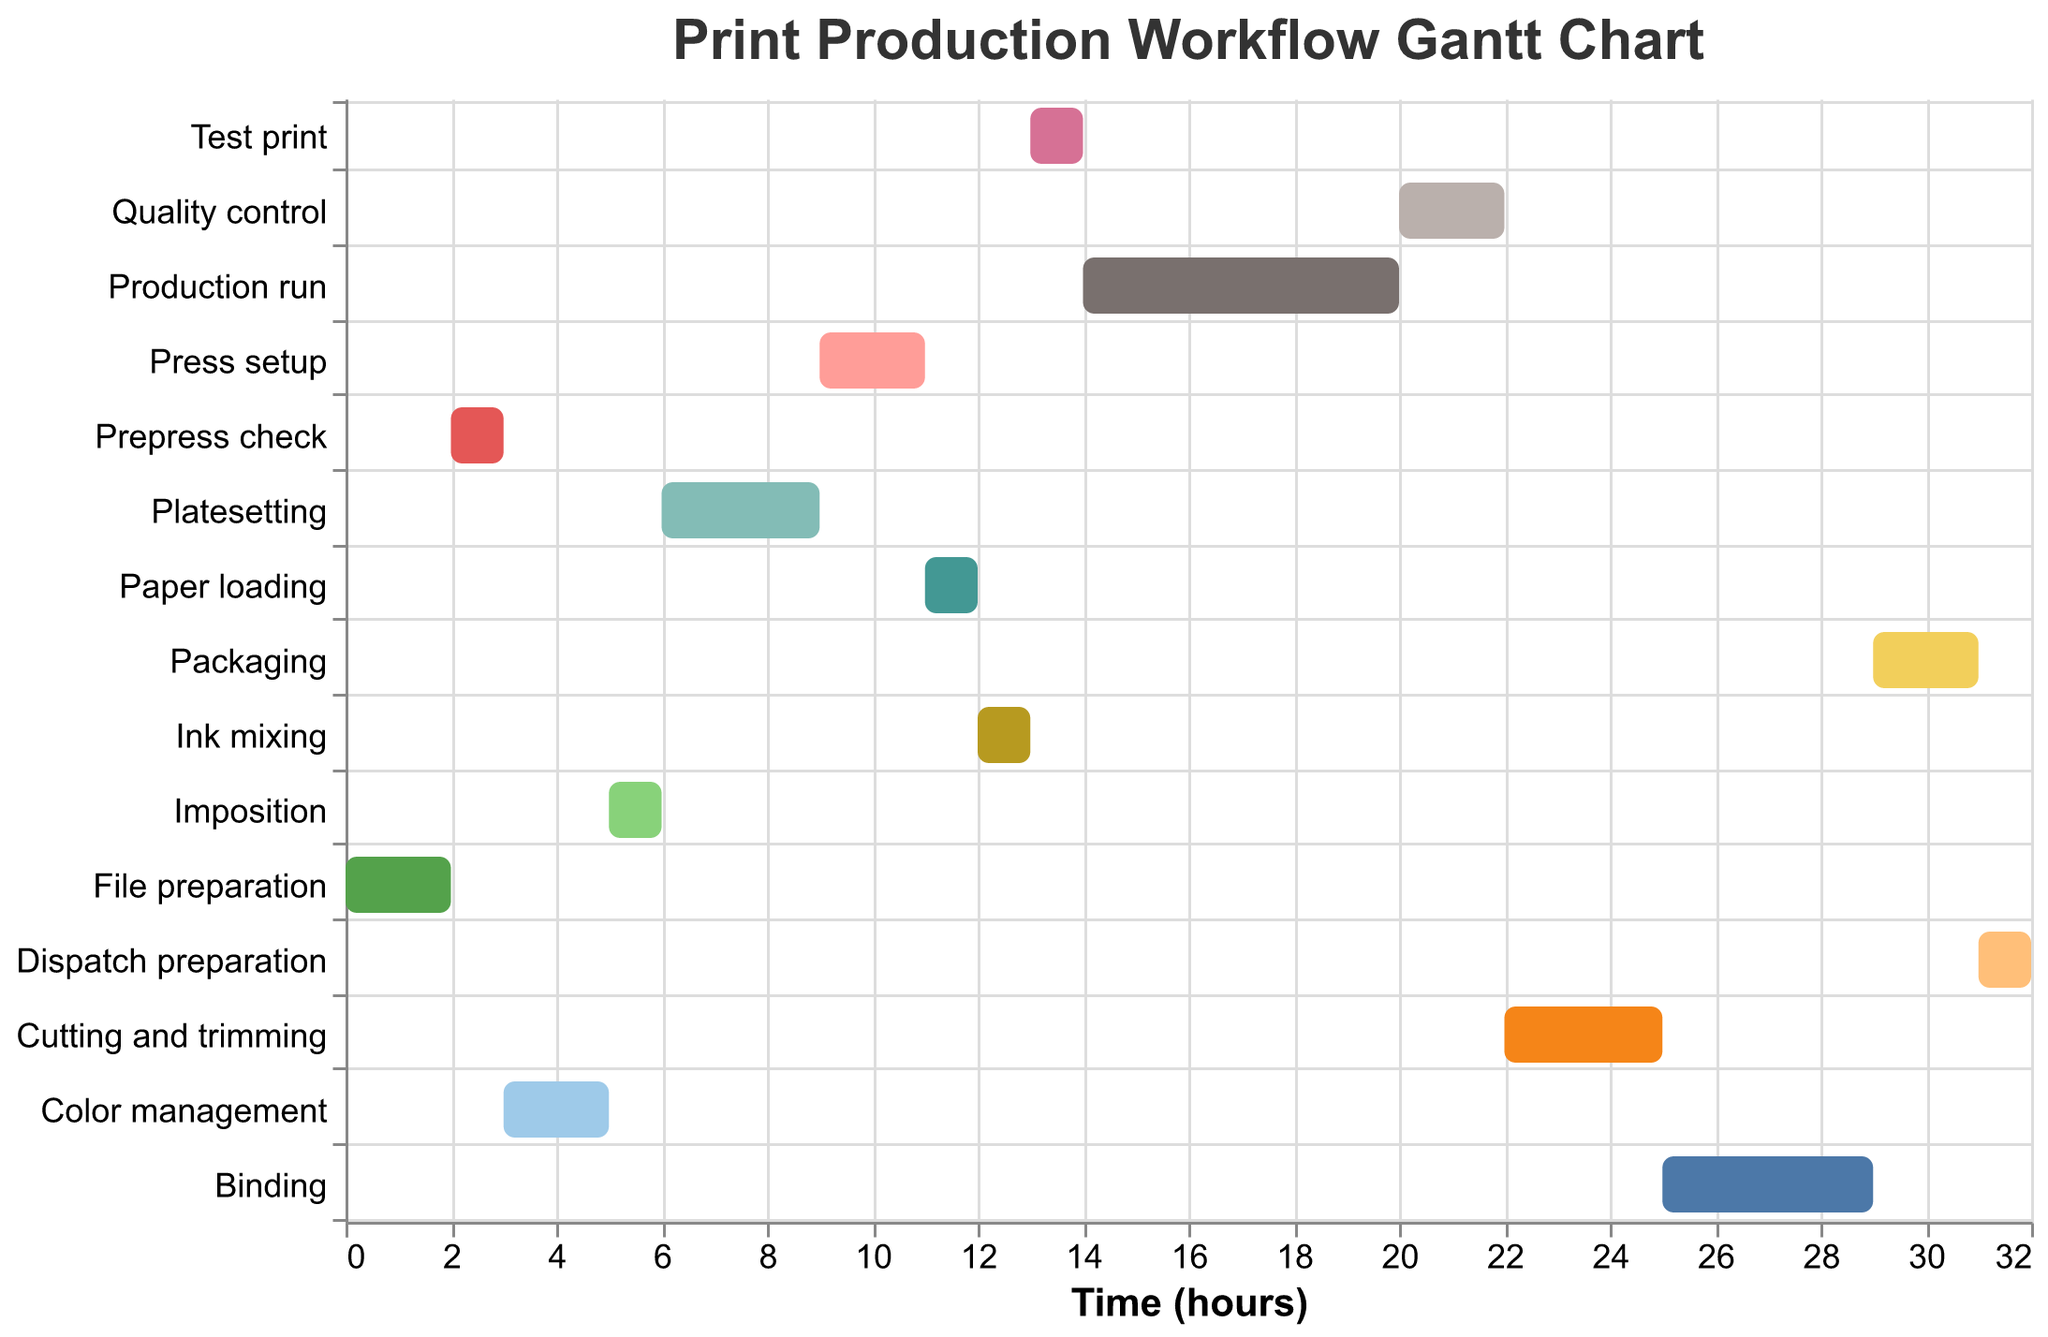What is the title of the chart? The title is usually found at the top of the chart and provides a description of what the chart represents.
Answer: Print Production Workflow Gantt Chart How long does the "Color management" stage take? This can be seen directly by looking at the "Color management" bar on the Gantt chart and checking its duration.
Answer: 2 hours What stage follows "File preparation"? To answer this, identify the task that starts immediately after "File preparation," which includes checking the start times and durations.
Answer: Prepress check Which task requires the most time to complete? Compare all the durations to find the task with the largest value.
Answer: Production run What is the total duration of the workflow from start to end? Sum up the durations of all tasks.
Answer: 32 hours How many stages take exactly 1 hour to complete? Count all the tasks with a duration of 1 hour.
Answer: 5 stages What is the difference in duration between "Platesetting" and "Binding"? Subtract the duration of "Binding" from "Platesetting".
Answer: 1 hour How much time does the "Production run" start after the "Prepress check" is completed? Calculate the difference between the start time of the "Production run" and the end time of the "Prepress check."
Answer: 12 hours Which task starts at hour 9? Find the task with a starting time of 9 hours.
Answer: Press setup During which hours does "Ink mixing" occur? Add the start time to the duration of "Ink mixing" to determine the range of hours it covers.
Answer: 12 to 13 hours 